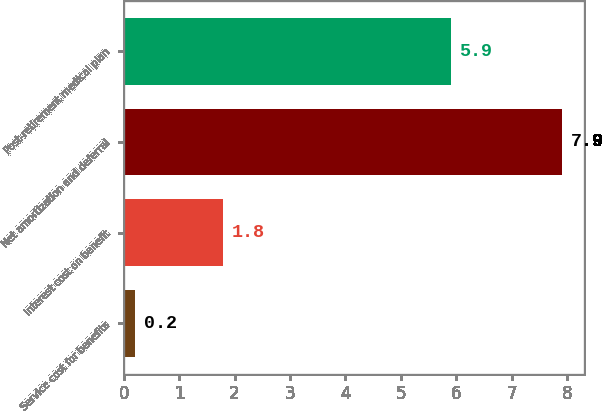Convert chart. <chart><loc_0><loc_0><loc_500><loc_500><bar_chart><fcel>Service cost for benefits<fcel>Interest cost on benefit<fcel>Net amortization and deferral<fcel>Post-retirement medical plan<nl><fcel>0.2<fcel>1.8<fcel>7.9<fcel>5.9<nl></chart> 